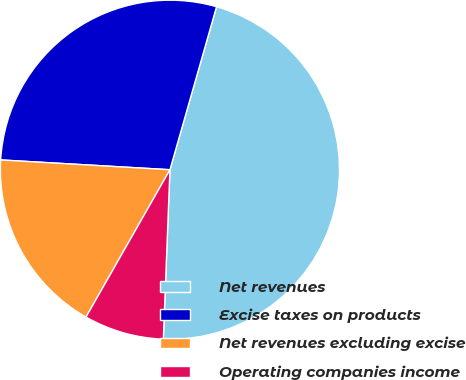<chart> <loc_0><loc_0><loc_500><loc_500><pie_chart><fcel>Net revenues<fcel>Excise taxes on products<fcel>Net revenues excluding excise<fcel>Operating companies income<nl><fcel>46.19%<fcel>28.51%<fcel>17.68%<fcel>7.62%<nl></chart> 